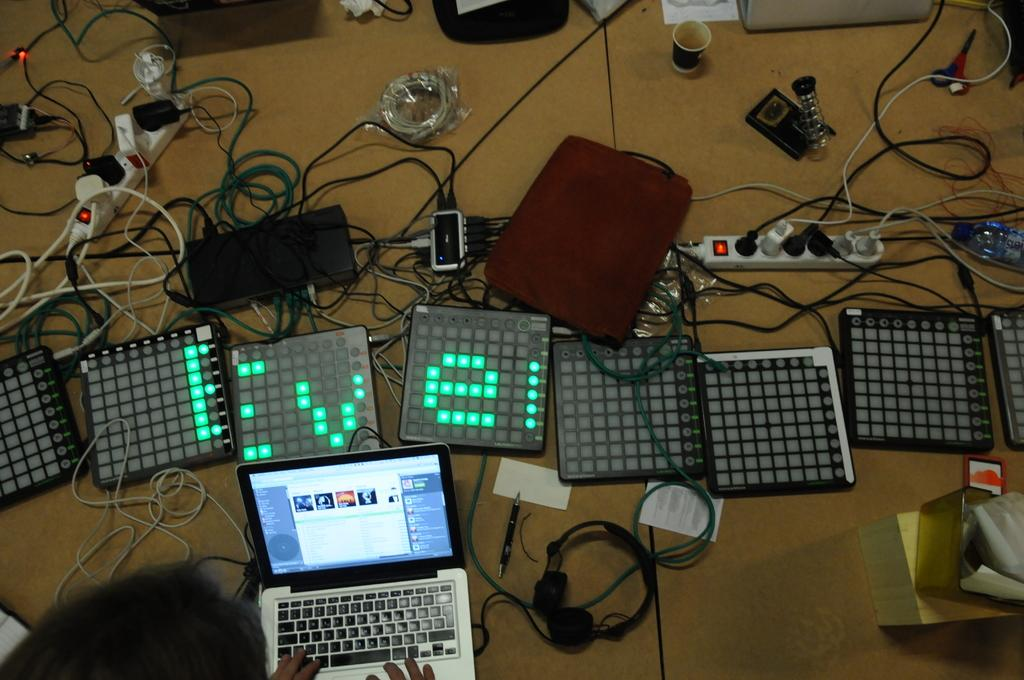<image>
Offer a succinct explanation of the picture presented. Macbook laptop in front of some electronic devices. 